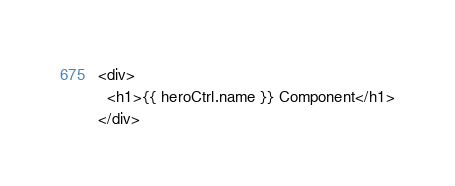<code> <loc_0><loc_0><loc_500><loc_500><_HTML_><div>
  <h1>{{ heroCtrl.name }} Component</h1>
</div>
</code> 